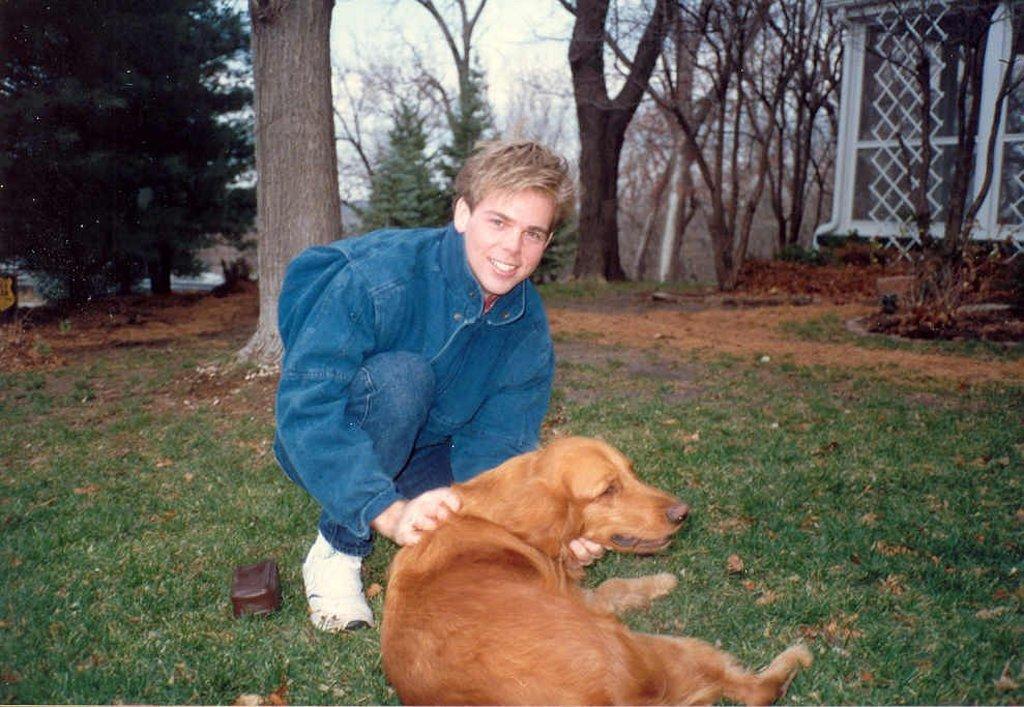Could you give a brief overview of what you see in this image? This picture shows a boy who is sitting on the grass. In front of a boy there is a dog. In the background there are some trees and a wall.. sky here. 